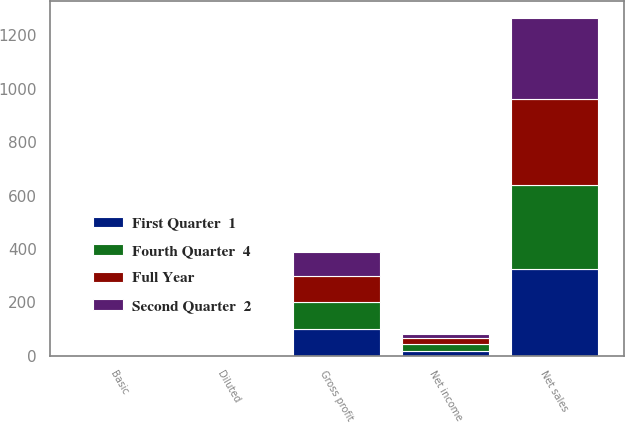Convert chart to OTSL. <chart><loc_0><loc_0><loc_500><loc_500><stacked_bar_chart><ecel><fcel>Net sales<fcel>Gross profit<fcel>Net income<fcel>Basic<fcel>Diluted<nl><fcel>Fourth Quarter  4<fcel>316.3<fcel>101.1<fcel>29.2<fcel>0.86<fcel>0.81<nl><fcel>First Quarter  1<fcel>324.8<fcel>98.7<fcel>15.6<fcel>0.46<fcel>0.45<nl><fcel>Second Quarter  2<fcel>303.8<fcel>90.4<fcel>14.8<fcel>0.43<fcel>0.43<nl><fcel>Full Year<fcel>321.5<fcel>97.5<fcel>21.1<fcel>0.62<fcel>0.6<nl></chart> 